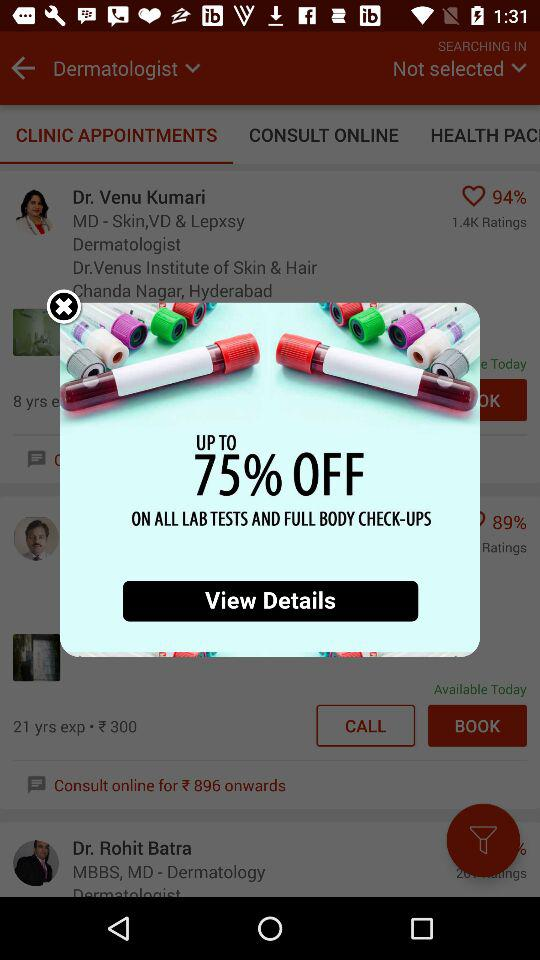How much discount can I get on all the lab tests and full body check-ups? You can get up to 75% off. 